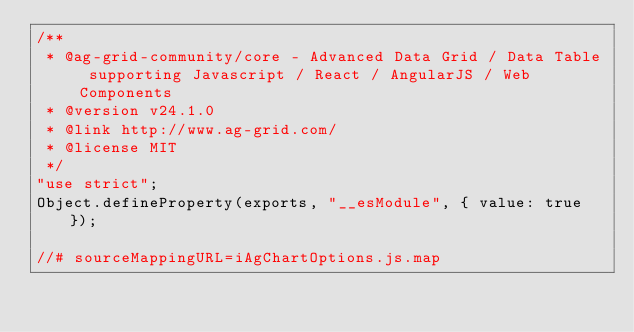Convert code to text. <code><loc_0><loc_0><loc_500><loc_500><_JavaScript_>/**
 * @ag-grid-community/core - Advanced Data Grid / Data Table supporting Javascript / React / AngularJS / Web Components
 * @version v24.1.0
 * @link http://www.ag-grid.com/
 * @license MIT
 */
"use strict";
Object.defineProperty(exports, "__esModule", { value: true });

//# sourceMappingURL=iAgChartOptions.js.map
</code> 